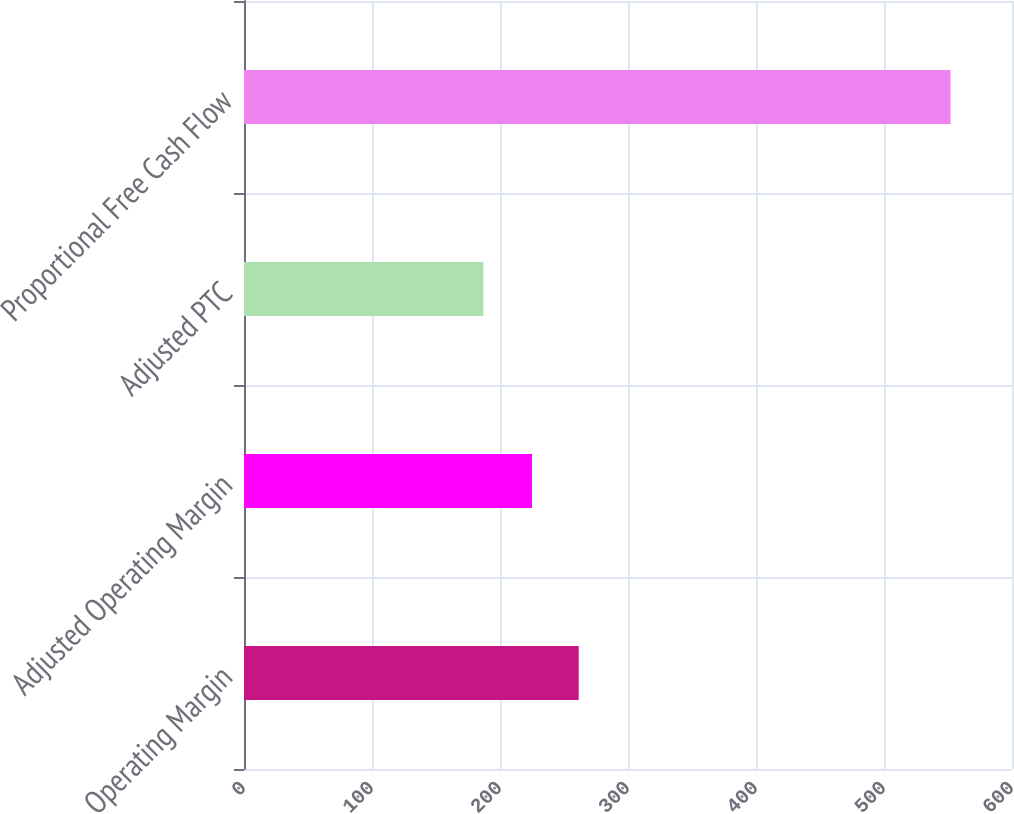Convert chart to OTSL. <chart><loc_0><loc_0><loc_500><loc_500><bar_chart><fcel>Operating Margin<fcel>Adjusted Operating Margin<fcel>Adjusted PTC<fcel>Proportional Free Cash Flow<nl><fcel>261.5<fcel>225<fcel>187<fcel>552<nl></chart> 